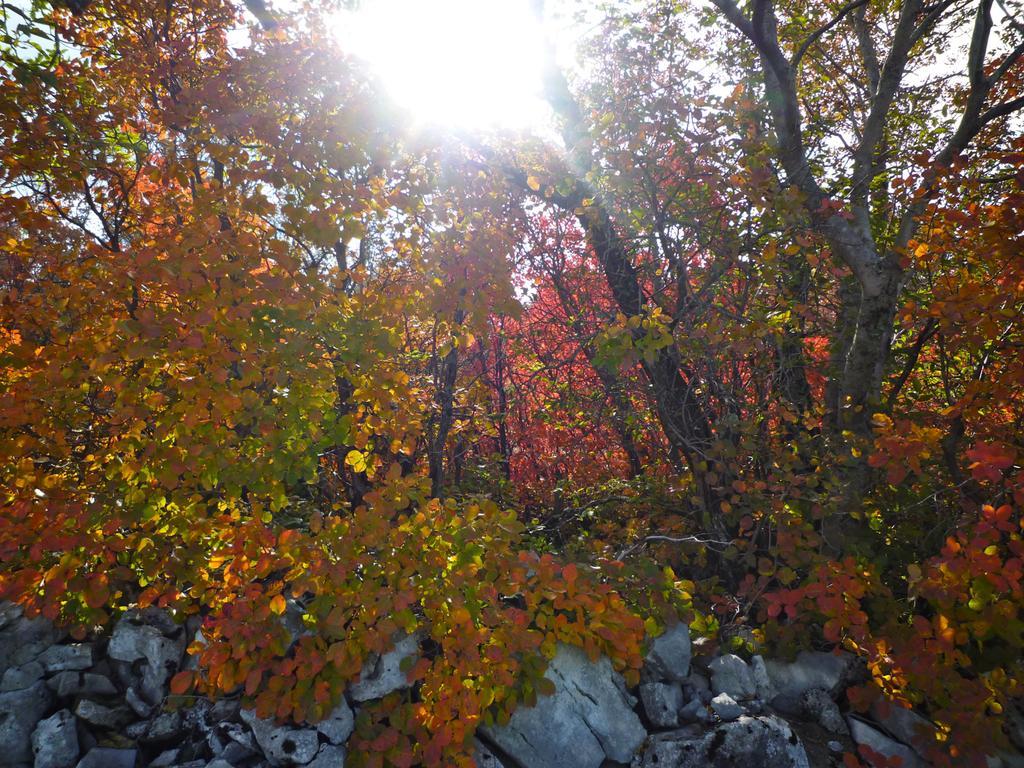Can you describe this image briefly? In the picture we can see some plants and trees with different colors of leaves like yellow, red and green and to the bottom we can see some rocks which are white in color and to the top we can see a sky with sunshine. 